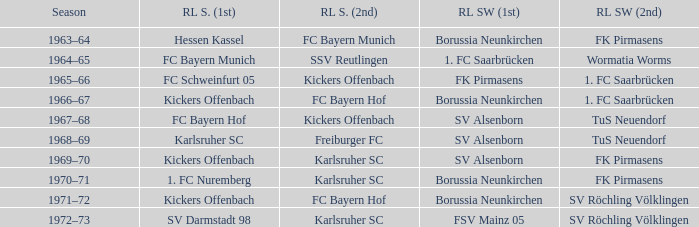Help me parse the entirety of this table. {'header': ['Season', 'RL S. (1st)', 'RL S. (2nd)', 'RL SW (1st)', 'RL SW (2nd)'], 'rows': [['1963–64', 'Hessen Kassel', 'FC Bayern Munich', 'Borussia Neunkirchen', 'FK Pirmasens'], ['1964–65', 'FC Bayern Munich', 'SSV Reutlingen', '1. FC Saarbrücken', 'Wormatia Worms'], ['1965–66', 'FC Schweinfurt 05', 'Kickers Offenbach', 'FK Pirmasens', '1. FC Saarbrücken'], ['1966–67', 'Kickers Offenbach', 'FC Bayern Hof', 'Borussia Neunkirchen', '1. FC Saarbrücken'], ['1967–68', 'FC Bayern Hof', 'Kickers Offenbach', 'SV Alsenborn', 'TuS Neuendorf'], ['1968–69', 'Karlsruher SC', 'Freiburger FC', 'SV Alsenborn', 'TuS Neuendorf'], ['1969–70', 'Kickers Offenbach', 'Karlsruher SC', 'SV Alsenborn', 'FK Pirmasens'], ['1970–71', '1. FC Nuremberg', 'Karlsruher SC', 'Borussia Neunkirchen', 'FK Pirmasens'], ['1971–72', 'Kickers Offenbach', 'FC Bayern Hof', 'Borussia Neunkirchen', 'SV Röchling Völklingen'], ['1972–73', 'SV Darmstadt 98', 'Karlsruher SC', 'FSV Mainz 05', 'SV Röchling Völklingen']]} Who was RL Süd (1st) when FK Pirmasens was RL Südwest (1st)? FC Schweinfurt 05. 